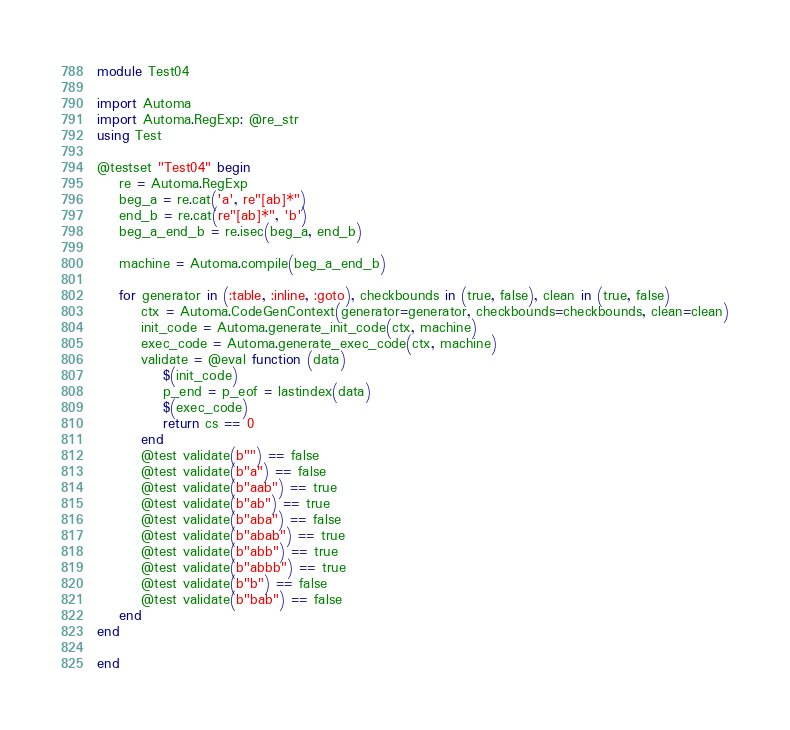Convert code to text. <code><loc_0><loc_0><loc_500><loc_500><_Julia_>module Test04

import Automa
import Automa.RegExp: @re_str
using Test

@testset "Test04" begin
    re = Automa.RegExp
    beg_a = re.cat('a', re"[ab]*")
    end_b = re.cat(re"[ab]*", 'b')
    beg_a_end_b = re.isec(beg_a, end_b)

    machine = Automa.compile(beg_a_end_b)

    for generator in (:table, :inline, :goto), checkbounds in (true, false), clean in (true, false)
        ctx = Automa.CodeGenContext(generator=generator, checkbounds=checkbounds, clean=clean)
        init_code = Automa.generate_init_code(ctx, machine)
        exec_code = Automa.generate_exec_code(ctx, machine)
        validate = @eval function (data)
            $(init_code)
            p_end = p_eof = lastindex(data)
            $(exec_code)
            return cs == 0
        end
        @test validate(b"") == false
        @test validate(b"a") == false
        @test validate(b"aab") == true
        @test validate(b"ab") == true
        @test validate(b"aba") == false
        @test validate(b"abab") == true
        @test validate(b"abb") == true
        @test validate(b"abbb") == true
        @test validate(b"b") == false
        @test validate(b"bab") == false
    end
end

end
</code> 